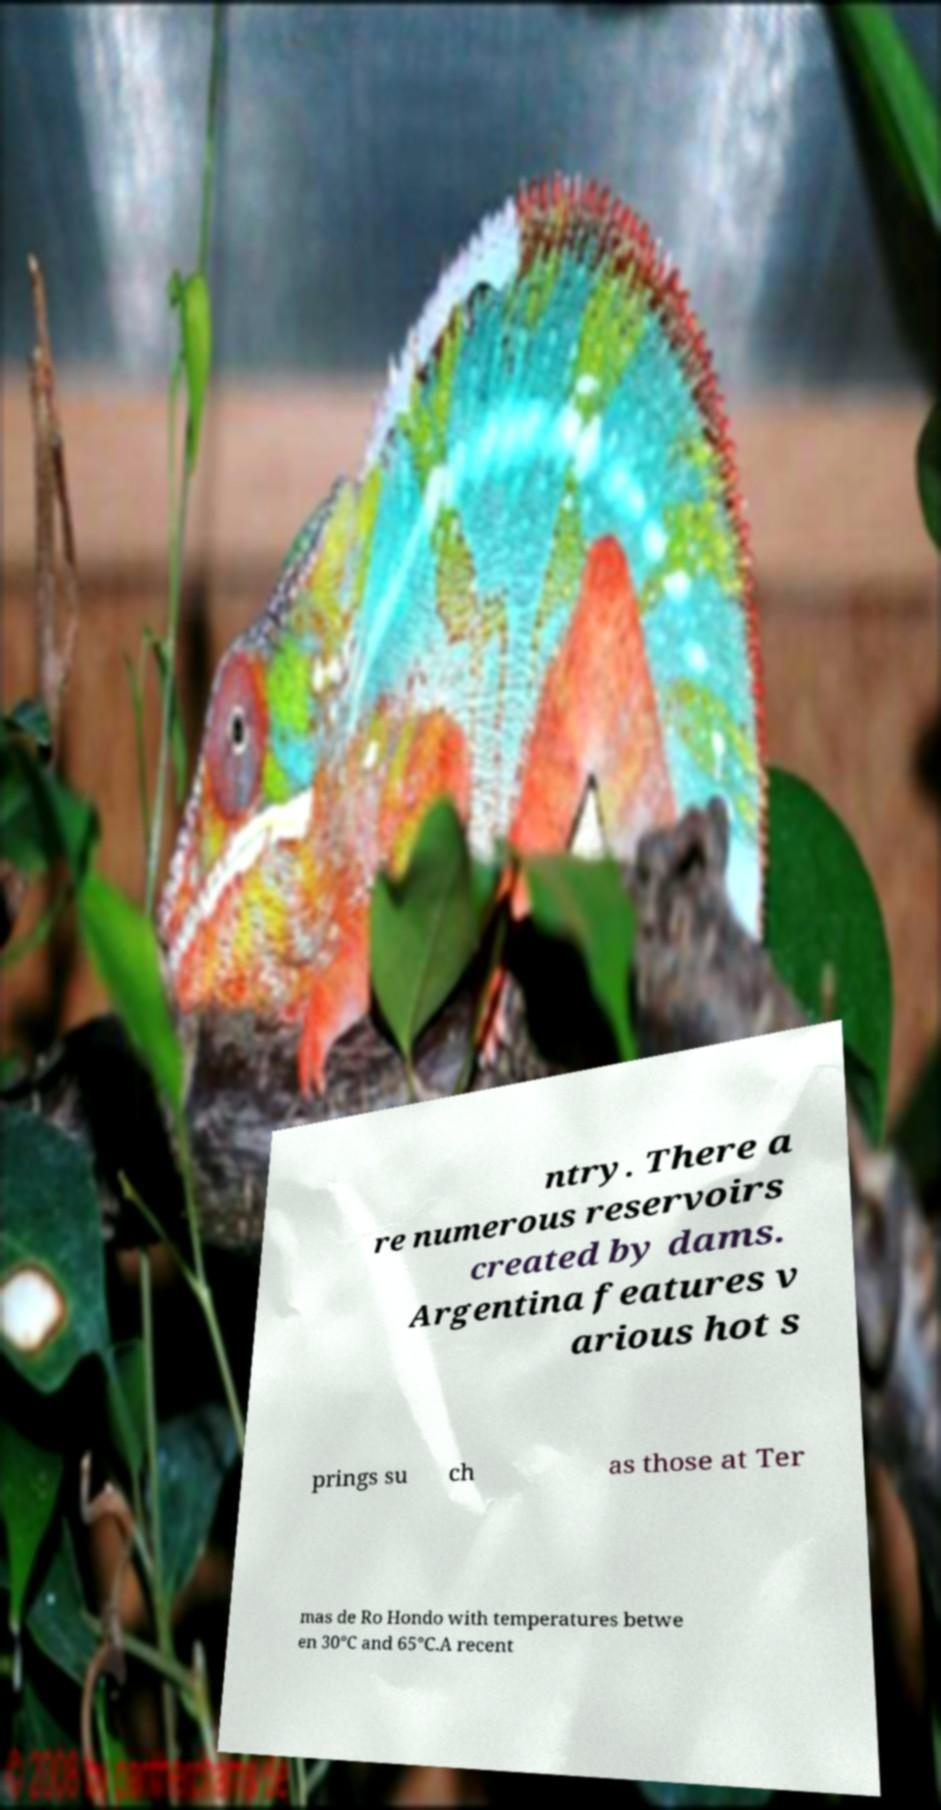Please read and relay the text visible in this image. What does it say? ntry. There a re numerous reservoirs created by dams. Argentina features v arious hot s prings su ch as those at Ter mas de Ro Hondo with temperatures betwe en 30°C and 65°C.A recent 